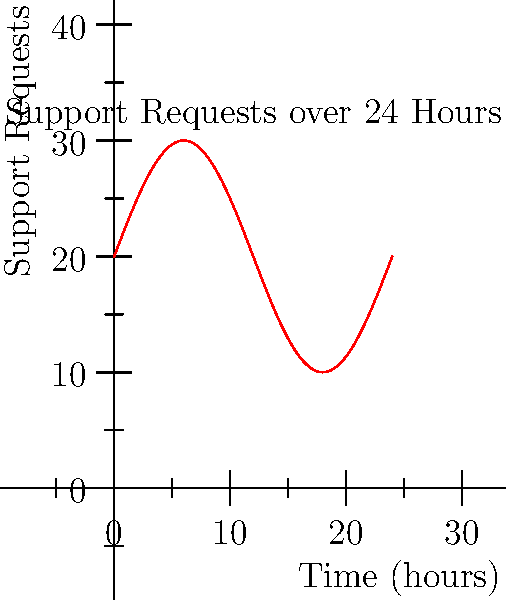Given the graph representing the number of incoming support requests over a 24-hour period, calculate the minimum number of support agents needed to handle the workload if each agent can process 60 requests per hour. Assume that agents work 8-hour shifts and the company wants to ensure all requests are handled within the hour they are received. To solve this problem, we need to follow these steps:

1) The function representing the number of support requests per hour is:
   $f(t) = 20 + 10\sin(\frac{\pi t}{12})$

2) To find the maximum number of requests in any given hour, we need to find the maximum value of this function over the 24-hour period.

3) The maximum occurs when $\sin(\frac{\pi t}{12}) = 1$, which gives:
   $f_{max} = 20 + 10 = 30$ requests per hour

4) If each agent can handle 60 requests per hour, the number of agents needed is:
   $\frac{30 \text{ requests/hour}}{60 \text{ requests/agent/hour}} = 0.5 \text{ agents}$

5) Since we can't have a fractional number of agents and we need to ensure all requests are handled within the hour, we round up to 1 agent.

6) However, agents work in 8-hour shifts, so we need to ensure we have coverage for all 24 hours. This means we need 3 shifts of 1 agent each.

Therefore, the minimum number of support agents needed is 3.
Answer: 3 agents 